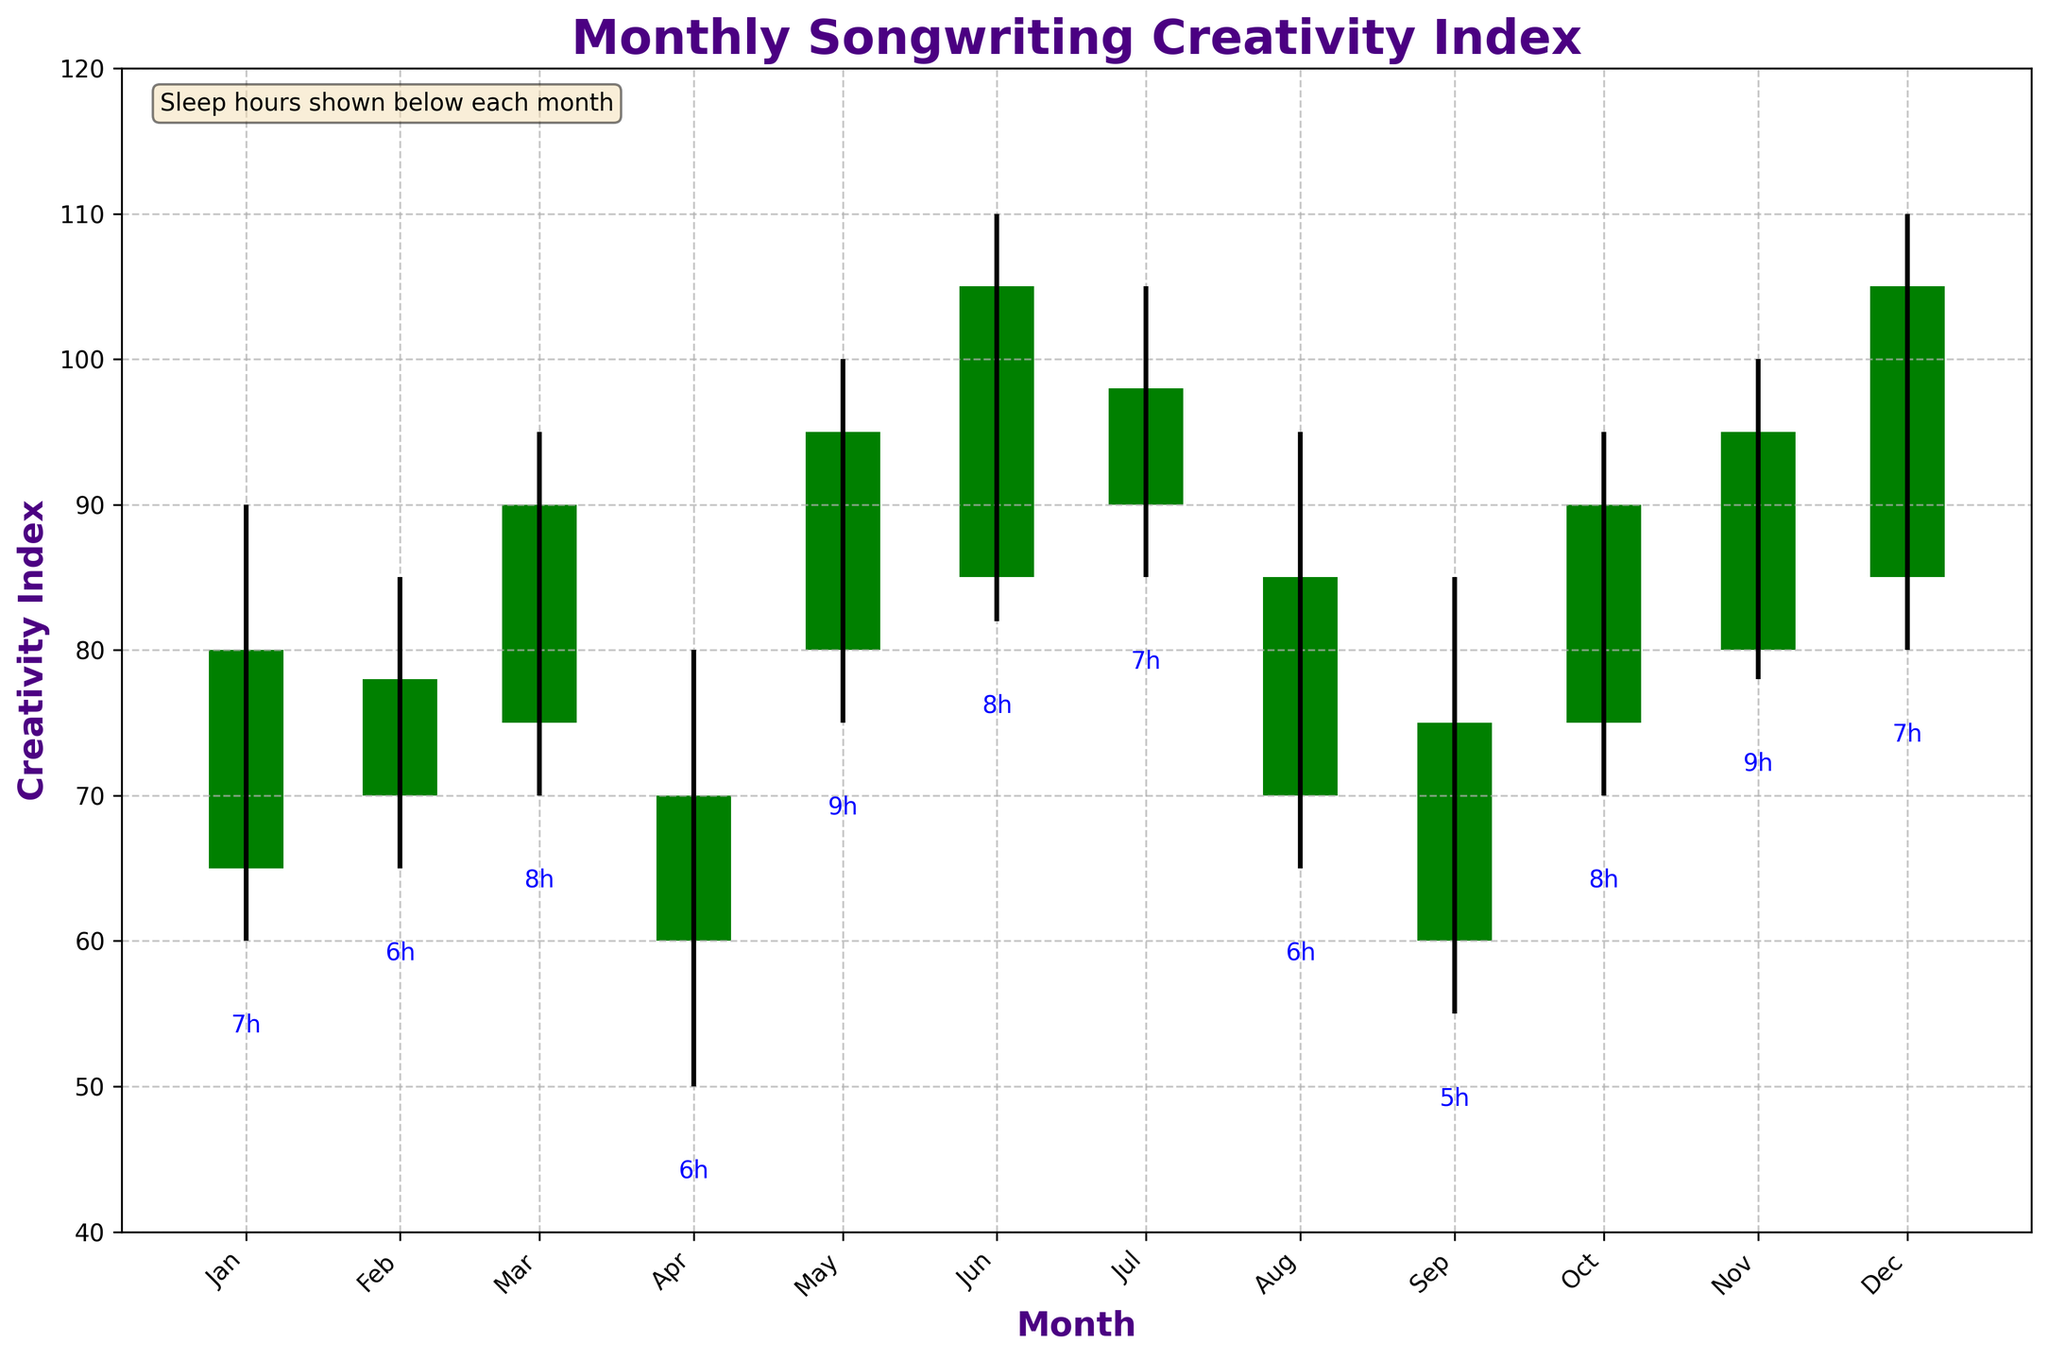What's the title of the figure? The title of the figure is written at the top of the plot.
Answer: Monthly Songwriting Creativity Index What is the creativity index in December? The creativity index for any given month can be found by looking at the 'Close' value for that month in the bars. For December, the 'Close' value is 105.
Answer: 105 Which month has the highest 'High' value? To find the month with the highest 'High' value, look for the month with the tallest candlestick reaching upwards. This occurs in June and December with a 'High' value of 110.
Answer: June and December What is the average sleep hours across the year? Add all the sleep hours for each month and divide by 12. The sum is (7+6+8+6+9+8+7+6+5+8+9+7), which is 86, so the average is 86/12.
Answer: 7.17 In which months did the 'Close' value decrease from the 'Open' value? For the months where the 'Close' value is less than the 'Open' value, the bar color is red. These months are April, August, and September.
Answer: April, August, September What is the difference between the 'High' value and 'Low' value in March? Subtract the 'Low' value from the 'High' value for March. The values are 95 and 70, respectively. The difference is 95 - 70.
Answer: 25 Which month has the lowest 'Low' value? Look for the candlestick with the lowest bottom point. This occurs in September with a 'Low' value of 55.
Answer: September What is the median 'Close' value over the year? To find the median, list all 'Close' values in ascending order and find the middle number. The values are 70, 75, 75, 78, 80, 85, 90, 90, 95, 95, 98, 105. The middle numbers are 85 and 90, so the median is (85+90)/2.
Answer: 87.5 How much did the 'Creativity Index' increase from April to May? Subtract the 'Close' value of April from the 'Close' value of May. The values are 95 (May) and 70 (April), so the increase is 95 - 70.
Answer: 25 Which months have a 'Close' value of 90? Look at the months with a closing value of 90. These occur in March, October, and July.
Answer: March, October, July 